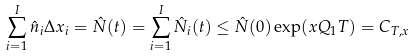<formula> <loc_0><loc_0><loc_500><loc_500>\sum _ { i = 1 } ^ { I } \hat { n } _ { i } \Delta x _ { i } = \hat { N } ( t ) = \sum _ { i = 1 } ^ { I } \hat { N } _ { i } ( t ) \leq \hat { N } ( 0 ) \exp ( x { Q } _ { 1 } T ) = C _ { T , x }</formula> 